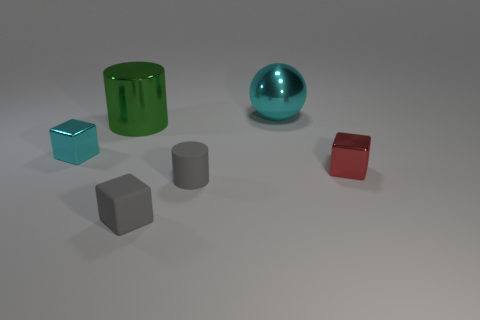There is a small metallic cube that is on the left side of the gray rubber block; what is its color?
Ensure brevity in your answer.  Cyan. What shape is the shiny thing that is both to the right of the big green thing and left of the small red metal thing?
Provide a succinct answer. Sphere. How many big purple things have the same shape as the small cyan thing?
Provide a succinct answer. 0. What number of cyan balls are there?
Your answer should be compact. 1. What size is the block that is behind the small gray cube and to the left of the red metallic thing?
Your answer should be very brief. Small. There is a gray rubber object that is the same size as the matte cylinder; what shape is it?
Ensure brevity in your answer.  Cube. Is there a large cylinder behind the cyan metal object that is to the right of the gray rubber cylinder?
Provide a short and direct response. No. There is another small shiny thing that is the same shape as the small red metal object; what is its color?
Keep it short and to the point. Cyan. There is a small object right of the sphere; is it the same color as the tiny rubber cube?
Keep it short and to the point. No. How many objects are tiny shiny things on the right side of the gray rubber cylinder or tiny cyan metallic cylinders?
Your answer should be very brief. 1. 